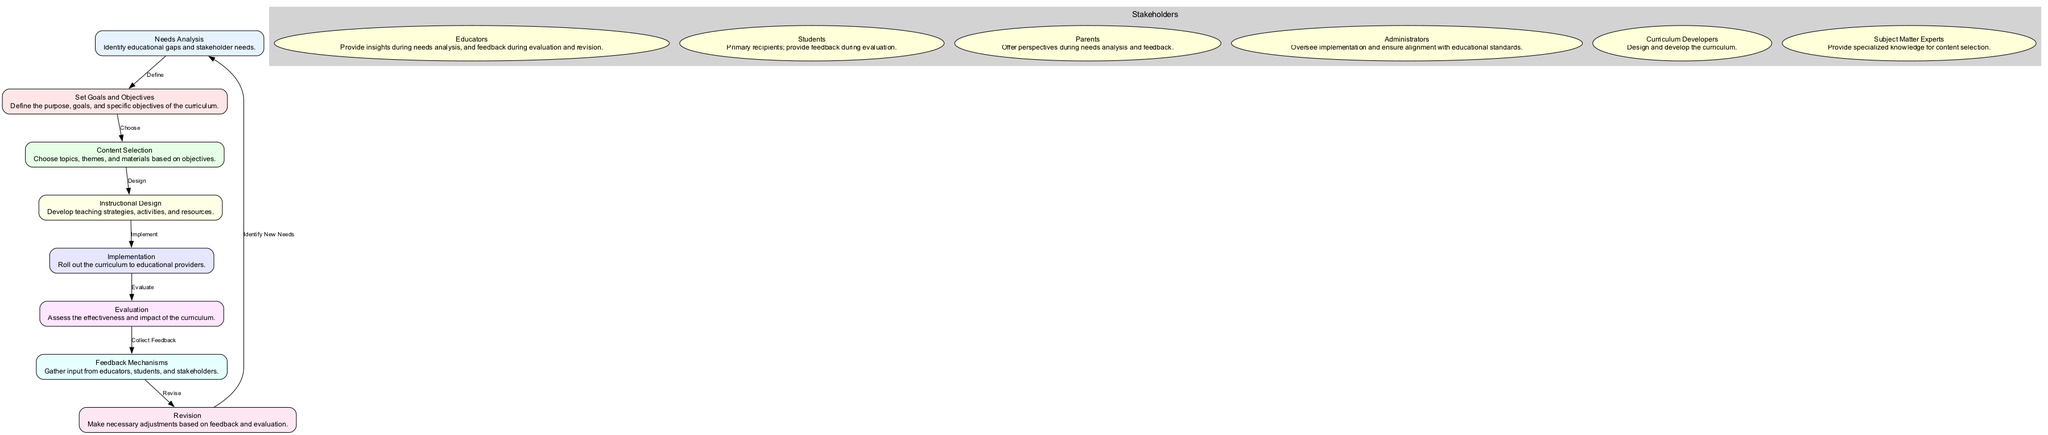What is the first step in the curriculum development process? The first step is "Needs Analysis" which identifies educational gaps and stakeholder needs.
Answer: Needs Analysis How many total nodes are there in the diagram? The diagram contains eight nodes representing distinct stages in the curriculum development process.
Answer: Eight What is the label of the node that follows "Implementation"? The node that follows "Implementation" is labeled "Evaluation".
Answer: Evaluation Which stakeholders provide feedback during the evaluation phase? Students and educators provide feedback during the evaluation phase as they have a role in assessing the curriculum's effectiveness.
Answer: Students, Educators What step comes after "Feedback Mechanisms"? The step that comes after "Feedback Mechanisms" is "Revision".
Answer: Revision Explain the relationship from "Content Selection" to "Instructional Design". "Content Selection" leads to "Instructional Design" as it involves designing teaching strategies based on the topics and themes chosen during content selection.
Answer: Design During which phase do curriculum developers primarily operate? Curriculum developers primarily operate in the "Instructional Design" phase where they design and develop the curriculum.
Answer: Instructional Design Which stakeholder offers perspectives during needs analysis? Parents offer perspectives during the needs analysis stage to help identify educational gaps and needs.
Answer: Parents What happens after "Evaluation"? The next step after "Evaluation" is to "Collect Feedback" from the stakeholders involved in the previous stages.
Answer: Collect Feedback 